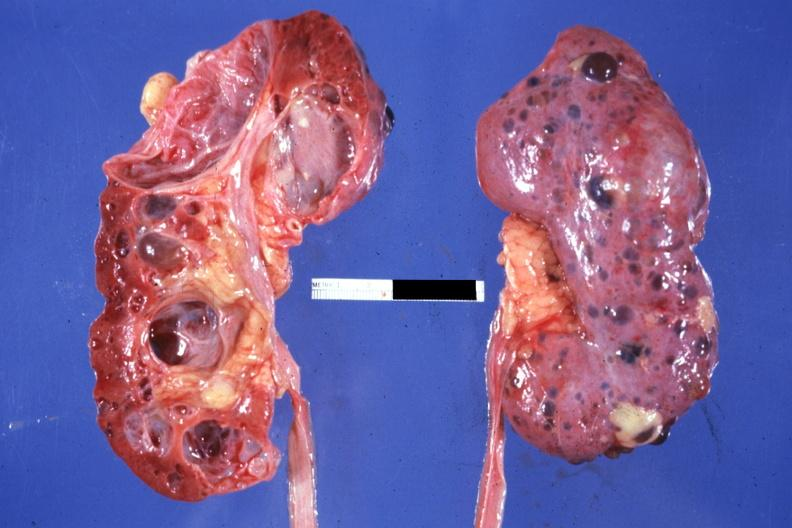what opened the other from capsular surface many cysts?
Answer the question using a single word or phrase. Nice photo one kidney 